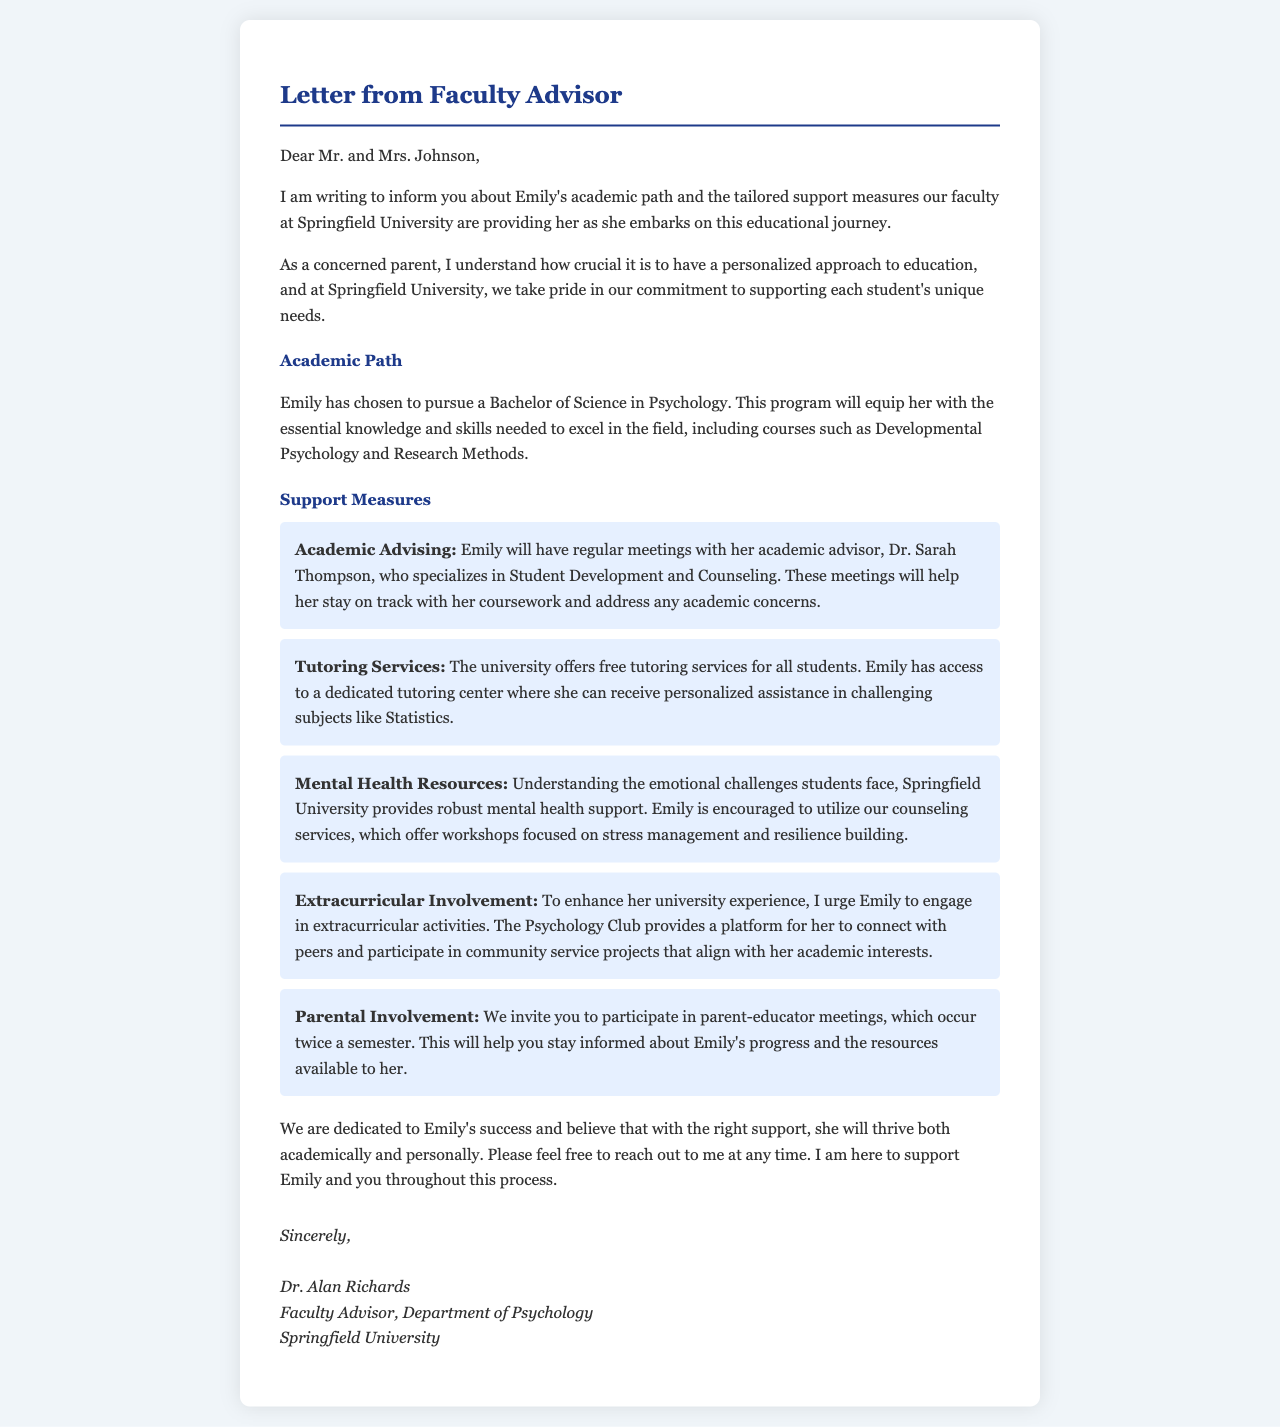What is Emily's major? The document states that Emily is pursuing a Bachelor of Science in Psychology, which is her chosen major.
Answer: Bachelor of Science in Psychology Who is Emily's academic advisor? The letter mentions that Emily will have regular meetings with her academic advisor, Dr. Sarah Thompson.
Answer: Dr. Sarah Thompson What course will Emily study that focuses on emotional challenges? The document lists various support measures, including counseling services focused on stress management and resilience building, indicating a course of study that addresses emotional challenges.
Answer: Stress management and resilience building How often are the parent-educator meetings held? According to the letter, parental involvement includes participating in meetings that occur twice a semester.
Answer: Twice a semester What type of academic support does the university provide for difficult subjects? The letter indicates that the university offers free tutoring services for students, which are specifically mentioned for assistance in challenging subjects like Statistics.
Answer: Free tutoring services 